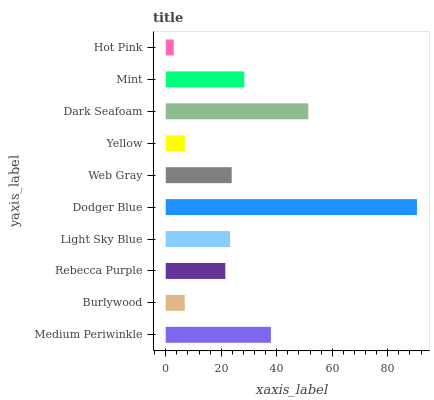Is Hot Pink the minimum?
Answer yes or no. Yes. Is Dodger Blue the maximum?
Answer yes or no. Yes. Is Burlywood the minimum?
Answer yes or no. No. Is Burlywood the maximum?
Answer yes or no. No. Is Medium Periwinkle greater than Burlywood?
Answer yes or no. Yes. Is Burlywood less than Medium Periwinkle?
Answer yes or no. Yes. Is Burlywood greater than Medium Periwinkle?
Answer yes or no. No. Is Medium Periwinkle less than Burlywood?
Answer yes or no. No. Is Web Gray the high median?
Answer yes or no. Yes. Is Light Sky Blue the low median?
Answer yes or no. Yes. Is Yellow the high median?
Answer yes or no. No. Is Rebecca Purple the low median?
Answer yes or no. No. 